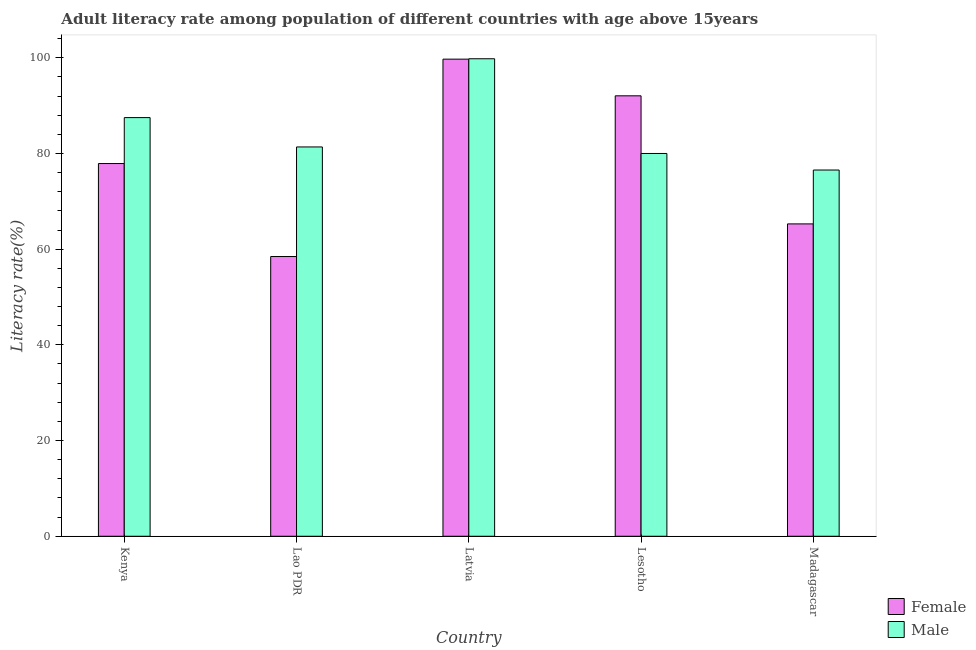How many different coloured bars are there?
Provide a succinct answer. 2. How many groups of bars are there?
Provide a short and direct response. 5. How many bars are there on the 1st tick from the right?
Provide a succinct answer. 2. What is the label of the 4th group of bars from the left?
Give a very brief answer. Lesotho. In how many cases, is the number of bars for a given country not equal to the number of legend labels?
Your answer should be very brief. 0. What is the male adult literacy rate in Lao PDR?
Keep it short and to the point. 81.36. Across all countries, what is the maximum female adult literacy rate?
Your response must be concise. 99.71. Across all countries, what is the minimum male adult literacy rate?
Provide a short and direct response. 76.54. In which country was the male adult literacy rate maximum?
Provide a short and direct response. Latvia. In which country was the female adult literacy rate minimum?
Your answer should be very brief. Lao PDR. What is the total female adult literacy rate in the graph?
Your answer should be compact. 393.39. What is the difference between the male adult literacy rate in Latvia and that in Lesotho?
Your response must be concise. 19.8. What is the difference between the male adult literacy rate in Madagascar and the female adult literacy rate in Latvia?
Your answer should be compact. -23.17. What is the average male adult literacy rate per country?
Make the answer very short. 85.04. What is the difference between the female adult literacy rate and male adult literacy rate in Lao PDR?
Your answer should be compact. -22.9. What is the ratio of the female adult literacy rate in Lao PDR to that in Madagascar?
Ensure brevity in your answer.  0.9. Is the female adult literacy rate in Kenya less than that in Lao PDR?
Keep it short and to the point. No. What is the difference between the highest and the second highest male adult literacy rate?
Your answer should be compact. 12.3. What is the difference between the highest and the lowest female adult literacy rate?
Your response must be concise. 41.25. In how many countries, is the male adult literacy rate greater than the average male adult literacy rate taken over all countries?
Ensure brevity in your answer.  2. What does the 1st bar from the left in Lesotho represents?
Provide a short and direct response. Female. How many countries are there in the graph?
Your response must be concise. 5. What is the title of the graph?
Offer a terse response. Adult literacy rate among population of different countries with age above 15years. Does "Females" appear as one of the legend labels in the graph?
Keep it short and to the point. No. What is the label or title of the X-axis?
Make the answer very short. Country. What is the label or title of the Y-axis?
Your answer should be very brief. Literacy rate(%). What is the Literacy rate(%) in Female in Kenya?
Your answer should be very brief. 77.89. What is the Literacy rate(%) of Male in Kenya?
Keep it short and to the point. 87.49. What is the Literacy rate(%) in Female in Lao PDR?
Ensure brevity in your answer.  58.46. What is the Literacy rate(%) of Male in Lao PDR?
Your answer should be very brief. 81.36. What is the Literacy rate(%) of Female in Latvia?
Your answer should be very brief. 99.71. What is the Literacy rate(%) in Male in Latvia?
Your response must be concise. 99.79. What is the Literacy rate(%) of Female in Lesotho?
Offer a terse response. 92.05. What is the Literacy rate(%) in Male in Lesotho?
Offer a terse response. 80. What is the Literacy rate(%) in Female in Madagascar?
Make the answer very short. 65.28. What is the Literacy rate(%) in Male in Madagascar?
Keep it short and to the point. 76.54. Across all countries, what is the maximum Literacy rate(%) of Female?
Your answer should be compact. 99.71. Across all countries, what is the maximum Literacy rate(%) of Male?
Provide a succinct answer. 99.79. Across all countries, what is the minimum Literacy rate(%) in Female?
Ensure brevity in your answer.  58.46. Across all countries, what is the minimum Literacy rate(%) of Male?
Ensure brevity in your answer.  76.54. What is the total Literacy rate(%) of Female in the graph?
Keep it short and to the point. 393.39. What is the total Literacy rate(%) in Male in the graph?
Your answer should be compact. 425.18. What is the difference between the Literacy rate(%) in Female in Kenya and that in Lao PDR?
Provide a succinct answer. 19.43. What is the difference between the Literacy rate(%) of Male in Kenya and that in Lao PDR?
Offer a terse response. 6.13. What is the difference between the Literacy rate(%) of Female in Kenya and that in Latvia?
Keep it short and to the point. -21.82. What is the difference between the Literacy rate(%) in Male in Kenya and that in Latvia?
Your answer should be very brief. -12.3. What is the difference between the Literacy rate(%) of Female in Kenya and that in Lesotho?
Provide a short and direct response. -14.15. What is the difference between the Literacy rate(%) in Male in Kenya and that in Lesotho?
Ensure brevity in your answer.  7.5. What is the difference between the Literacy rate(%) of Female in Kenya and that in Madagascar?
Your answer should be very brief. 12.61. What is the difference between the Literacy rate(%) of Male in Kenya and that in Madagascar?
Make the answer very short. 10.96. What is the difference between the Literacy rate(%) of Female in Lao PDR and that in Latvia?
Ensure brevity in your answer.  -41.25. What is the difference between the Literacy rate(%) of Male in Lao PDR and that in Latvia?
Offer a terse response. -18.43. What is the difference between the Literacy rate(%) of Female in Lao PDR and that in Lesotho?
Provide a succinct answer. -33.59. What is the difference between the Literacy rate(%) of Male in Lao PDR and that in Lesotho?
Provide a succinct answer. 1.36. What is the difference between the Literacy rate(%) of Female in Lao PDR and that in Madagascar?
Offer a terse response. -6.82. What is the difference between the Literacy rate(%) in Male in Lao PDR and that in Madagascar?
Your answer should be compact. 4.82. What is the difference between the Literacy rate(%) of Female in Latvia and that in Lesotho?
Keep it short and to the point. 7.66. What is the difference between the Literacy rate(%) of Male in Latvia and that in Lesotho?
Make the answer very short. 19.8. What is the difference between the Literacy rate(%) in Female in Latvia and that in Madagascar?
Your answer should be compact. 34.43. What is the difference between the Literacy rate(%) in Male in Latvia and that in Madagascar?
Provide a succinct answer. 23.25. What is the difference between the Literacy rate(%) in Female in Lesotho and that in Madagascar?
Provide a short and direct response. 26.77. What is the difference between the Literacy rate(%) of Male in Lesotho and that in Madagascar?
Provide a succinct answer. 3.46. What is the difference between the Literacy rate(%) of Female in Kenya and the Literacy rate(%) of Male in Lao PDR?
Offer a very short reply. -3.47. What is the difference between the Literacy rate(%) in Female in Kenya and the Literacy rate(%) in Male in Latvia?
Keep it short and to the point. -21.9. What is the difference between the Literacy rate(%) in Female in Kenya and the Literacy rate(%) in Male in Lesotho?
Ensure brevity in your answer.  -2.1. What is the difference between the Literacy rate(%) in Female in Kenya and the Literacy rate(%) in Male in Madagascar?
Make the answer very short. 1.35. What is the difference between the Literacy rate(%) of Female in Lao PDR and the Literacy rate(%) of Male in Latvia?
Your answer should be very brief. -41.33. What is the difference between the Literacy rate(%) of Female in Lao PDR and the Literacy rate(%) of Male in Lesotho?
Ensure brevity in your answer.  -21.54. What is the difference between the Literacy rate(%) in Female in Lao PDR and the Literacy rate(%) in Male in Madagascar?
Keep it short and to the point. -18.08. What is the difference between the Literacy rate(%) of Female in Latvia and the Literacy rate(%) of Male in Lesotho?
Provide a short and direct response. 19.71. What is the difference between the Literacy rate(%) in Female in Latvia and the Literacy rate(%) in Male in Madagascar?
Keep it short and to the point. 23.17. What is the difference between the Literacy rate(%) of Female in Lesotho and the Literacy rate(%) of Male in Madagascar?
Offer a terse response. 15.51. What is the average Literacy rate(%) of Female per country?
Make the answer very short. 78.68. What is the average Literacy rate(%) of Male per country?
Give a very brief answer. 85.04. What is the difference between the Literacy rate(%) of Female and Literacy rate(%) of Male in Kenya?
Your answer should be very brief. -9.6. What is the difference between the Literacy rate(%) in Female and Literacy rate(%) in Male in Lao PDR?
Provide a short and direct response. -22.9. What is the difference between the Literacy rate(%) in Female and Literacy rate(%) in Male in Latvia?
Keep it short and to the point. -0.08. What is the difference between the Literacy rate(%) in Female and Literacy rate(%) in Male in Lesotho?
Provide a succinct answer. 12.05. What is the difference between the Literacy rate(%) in Female and Literacy rate(%) in Male in Madagascar?
Make the answer very short. -11.26. What is the ratio of the Literacy rate(%) in Female in Kenya to that in Lao PDR?
Ensure brevity in your answer.  1.33. What is the ratio of the Literacy rate(%) of Male in Kenya to that in Lao PDR?
Ensure brevity in your answer.  1.08. What is the ratio of the Literacy rate(%) of Female in Kenya to that in Latvia?
Your answer should be very brief. 0.78. What is the ratio of the Literacy rate(%) in Male in Kenya to that in Latvia?
Provide a succinct answer. 0.88. What is the ratio of the Literacy rate(%) of Female in Kenya to that in Lesotho?
Make the answer very short. 0.85. What is the ratio of the Literacy rate(%) of Male in Kenya to that in Lesotho?
Your answer should be very brief. 1.09. What is the ratio of the Literacy rate(%) in Female in Kenya to that in Madagascar?
Provide a short and direct response. 1.19. What is the ratio of the Literacy rate(%) of Male in Kenya to that in Madagascar?
Ensure brevity in your answer.  1.14. What is the ratio of the Literacy rate(%) in Female in Lao PDR to that in Latvia?
Your answer should be very brief. 0.59. What is the ratio of the Literacy rate(%) of Male in Lao PDR to that in Latvia?
Provide a succinct answer. 0.82. What is the ratio of the Literacy rate(%) of Female in Lao PDR to that in Lesotho?
Ensure brevity in your answer.  0.64. What is the ratio of the Literacy rate(%) in Male in Lao PDR to that in Lesotho?
Offer a terse response. 1.02. What is the ratio of the Literacy rate(%) in Female in Lao PDR to that in Madagascar?
Offer a very short reply. 0.9. What is the ratio of the Literacy rate(%) in Male in Lao PDR to that in Madagascar?
Your response must be concise. 1.06. What is the ratio of the Literacy rate(%) in Male in Latvia to that in Lesotho?
Offer a terse response. 1.25. What is the ratio of the Literacy rate(%) of Female in Latvia to that in Madagascar?
Your response must be concise. 1.53. What is the ratio of the Literacy rate(%) of Male in Latvia to that in Madagascar?
Provide a short and direct response. 1.3. What is the ratio of the Literacy rate(%) of Female in Lesotho to that in Madagascar?
Your answer should be compact. 1.41. What is the ratio of the Literacy rate(%) in Male in Lesotho to that in Madagascar?
Provide a succinct answer. 1.05. What is the difference between the highest and the second highest Literacy rate(%) of Female?
Keep it short and to the point. 7.66. What is the difference between the highest and the second highest Literacy rate(%) of Male?
Your answer should be compact. 12.3. What is the difference between the highest and the lowest Literacy rate(%) in Female?
Give a very brief answer. 41.25. What is the difference between the highest and the lowest Literacy rate(%) of Male?
Make the answer very short. 23.25. 